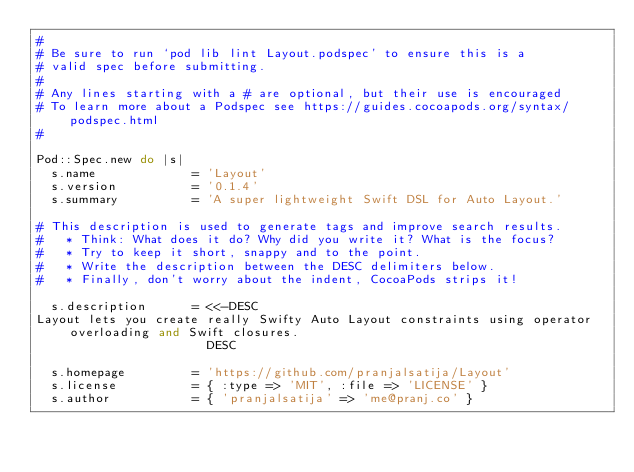<code> <loc_0><loc_0><loc_500><loc_500><_Ruby_>#
# Be sure to run `pod lib lint Layout.podspec' to ensure this is a
# valid spec before submitting.
#
# Any lines starting with a # are optional, but their use is encouraged
# To learn more about a Podspec see https://guides.cocoapods.org/syntax/podspec.html
#

Pod::Spec.new do |s|
  s.name             = 'Layout'
  s.version          = '0.1.4'
  s.summary          = 'A super lightweight Swift DSL for Auto Layout.'

# This description is used to generate tags and improve search results.
#   * Think: What does it do? Why did you write it? What is the focus?
#   * Try to keep it short, snappy and to the point.
#   * Write the description between the DESC delimiters below.
#   * Finally, don't worry about the indent, CocoaPods strips it!

  s.description      = <<-DESC
Layout lets you create really Swifty Auto Layout constraints using operator overloading and Swift closures.
                       DESC

  s.homepage         = 'https://github.com/pranjalsatija/Layout'
  s.license          = { :type => 'MIT', :file => 'LICENSE' }
  s.author           = { 'pranjalsatija' => 'me@pranj.co' }</code> 